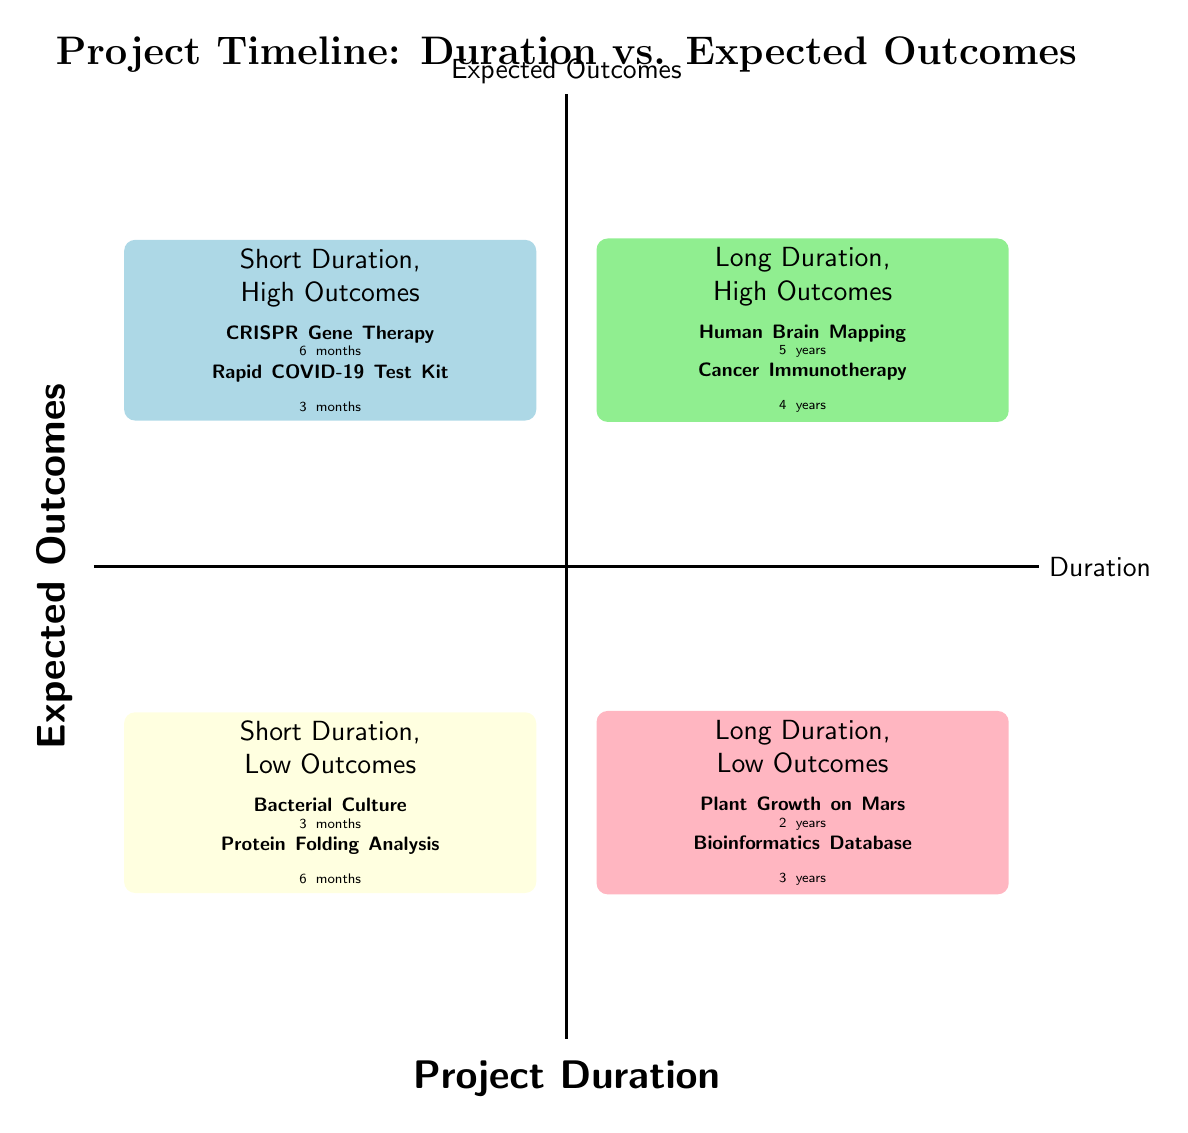What projects are listed in the Short Duration, High Outcomes quadrant? The diagram indicates that the projects in this quadrant are "CRISPR Gene Therapy" and "Rapid COVID-19 Test Kit Development."
Answer: CRISPR Gene Therapy, Rapid COVID-19 Test Kit Development How many projects have a duration of 5 years? The diagram shows that there is one project listed with a duration of 5 years, which is "Human Brain Mapping."
Answer: 1 Which quadrant contains projects with Long Duration and Low Outcomes? The diagram identifies that the quadrant labeled "Long Duration, Low Outcomes" has projects. This is the fourth quadrant (Q4).
Answer: Q4 What is the impact of the "Cancer Immunotherapy Research" project? The diagram states that the impact of this project is "Next-gen personalized treatments."
Answer: Next-gen personalized treatments Which project listed has the shortest duration? Among the projects, "Rapid COVID-19 Test Kit Development" has the shortest duration at 3 months.
Answer: 3 months Which quadrant features projects with both Short Duration and Low Outcomes? The diagram clearly places "Short Duration, Low Outcomes" in the third quadrant (Q3).
Answer: Q3 How many projects have high expected outcomes? The diagram shows that there are four projects with high expected outcomes, two in each of the first two quadrants.
Answer: 4 What duration does the project "Plant Growth Study on Mars Soil" have? The diagram indicates that this project has a duration of 2 years.
Answer: 2 years Which project has the longest duration in the diagram? According to the diagram, the longest duration project is "Human Brain Mapping" with a duration of 5 years.
Answer: Human Brain Mapping 